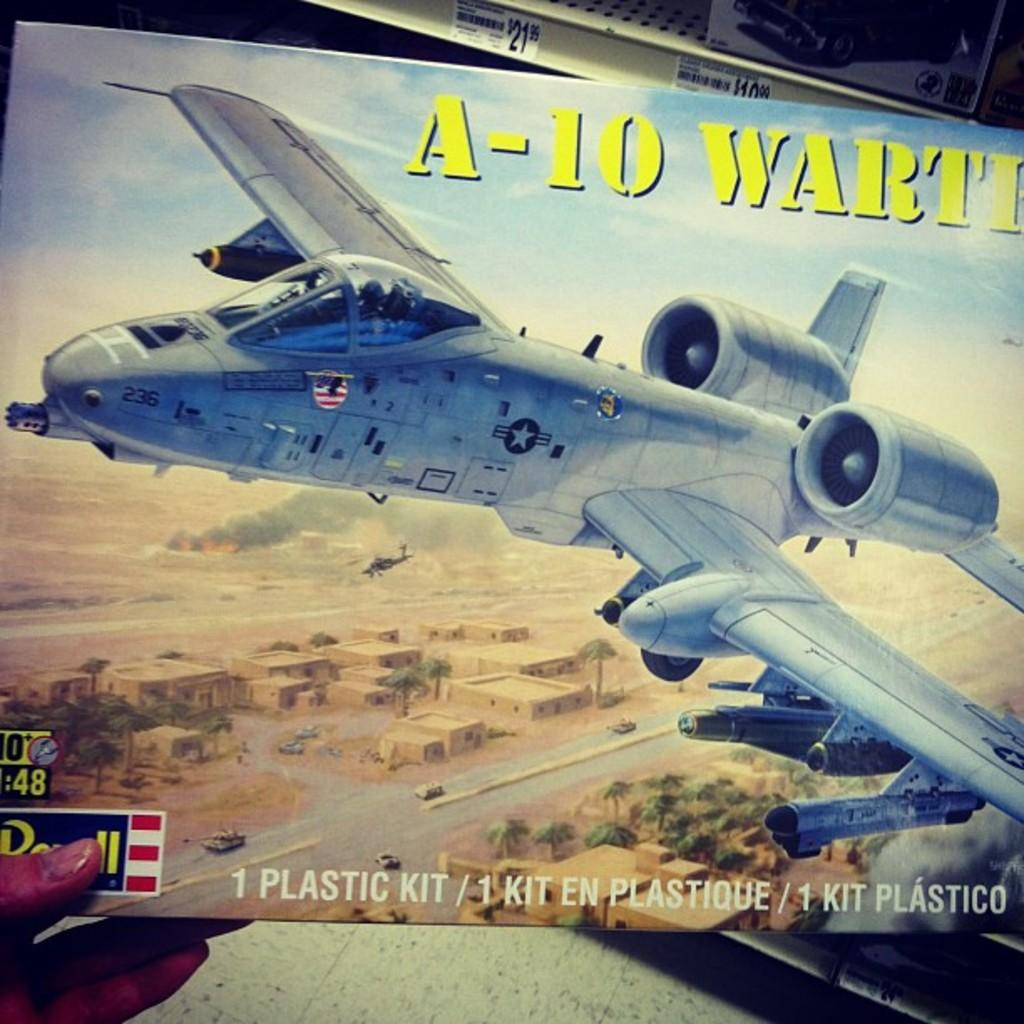Provide a one-sentence caption for the provided image. A box of  a plastic toy kit of A-10 is held up by the hand. 